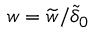Convert formula to latex. <formula><loc_0><loc_0><loc_500><loc_500>w = \widetilde { w } / \widetilde { \delta } _ { 0 }</formula> 